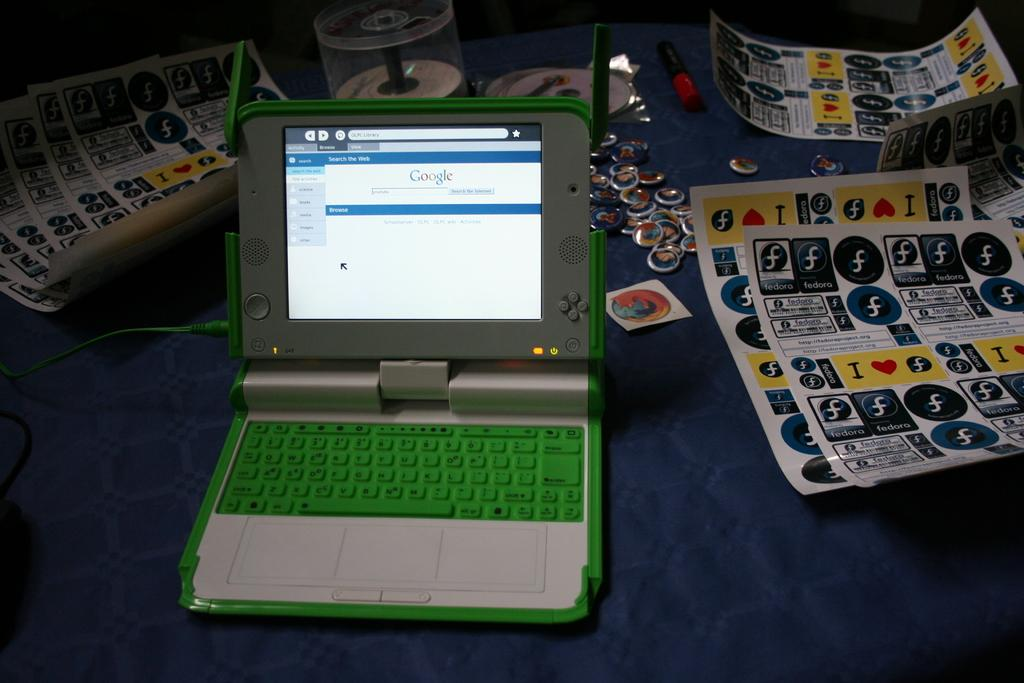<image>
Give a short and clear explanation of the subsequent image. A sheet of stickers with F on them are to the right of the laptop. 